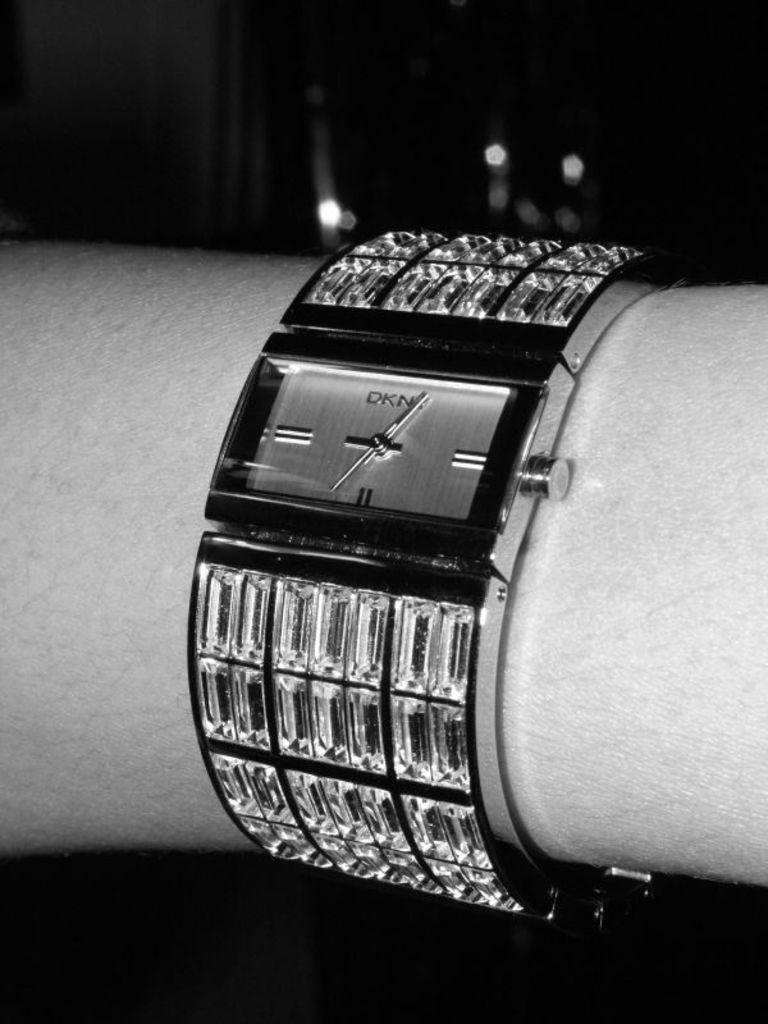What object is featured on a hand in the image? There is a watch on a hand in the image. What is the color scheme of the image? The image is black and white. What can be observed in the background of the image? The background of the image is completely dark. How many nerves are visible in the image? There are no nerves visible in the image; it features a watch on a hand. Is there a fan in the image? There is no fan present in the image. 